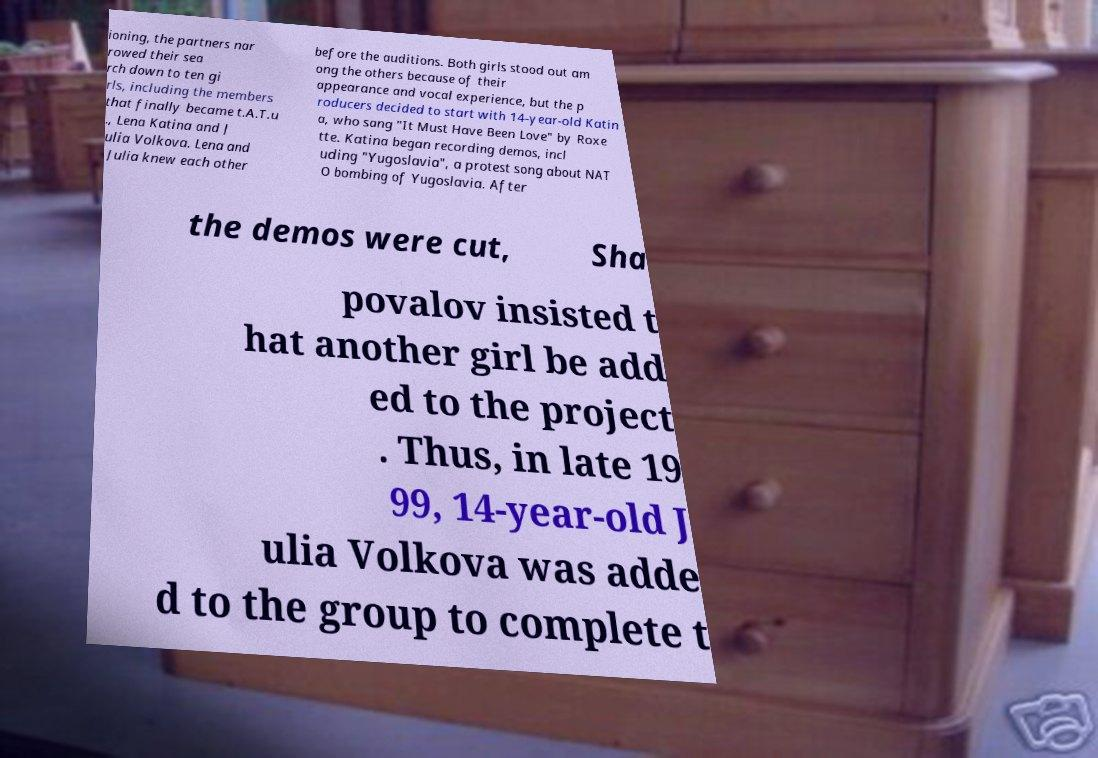Please identify and transcribe the text found in this image. ioning, the partners nar rowed their sea rch down to ten gi rls, including the members that finally became t.A.T.u ., Lena Katina and J ulia Volkova. Lena and Julia knew each other before the auditions. Both girls stood out am ong the others because of their appearance and vocal experience, but the p roducers decided to start with 14-year-old Katin a, who sang "It Must Have Been Love" by Roxe tte. Katina began recording demos, incl uding "Yugoslavia", a protest song about NAT O bombing of Yugoslavia. After the demos were cut, Sha povalov insisted t hat another girl be add ed to the project . Thus, in late 19 99, 14-year-old J ulia Volkova was adde d to the group to complete t 